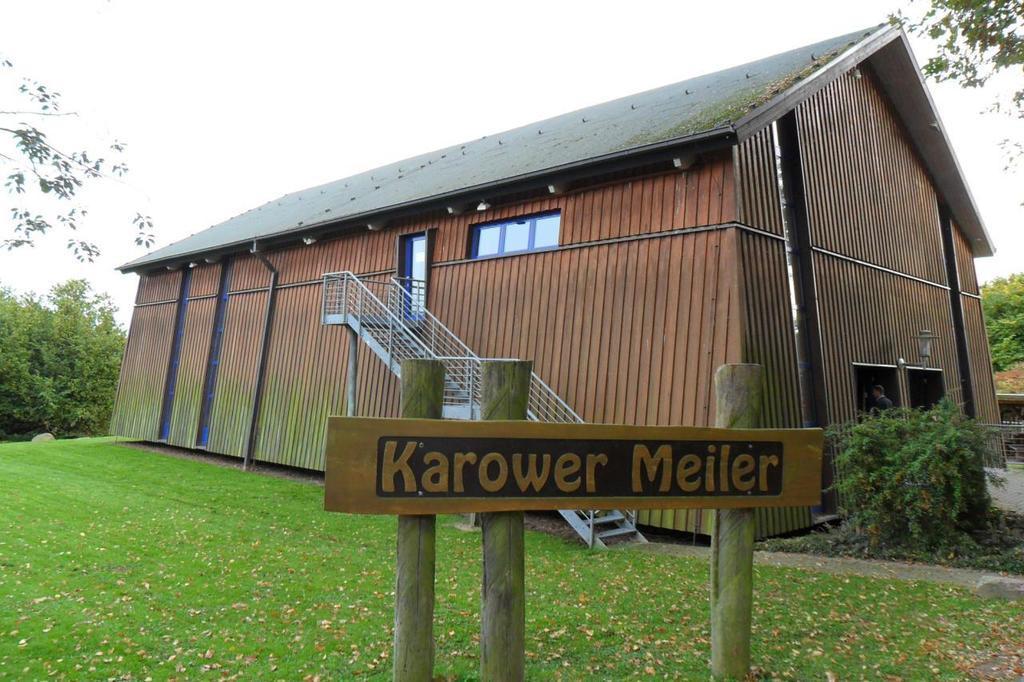Could you give a brief overview of what you see in this image? In this picture I can see a shed. There are staircase holders, stairs, board with poles, plants. I can see a person, and in the background there are trees and the sky. 